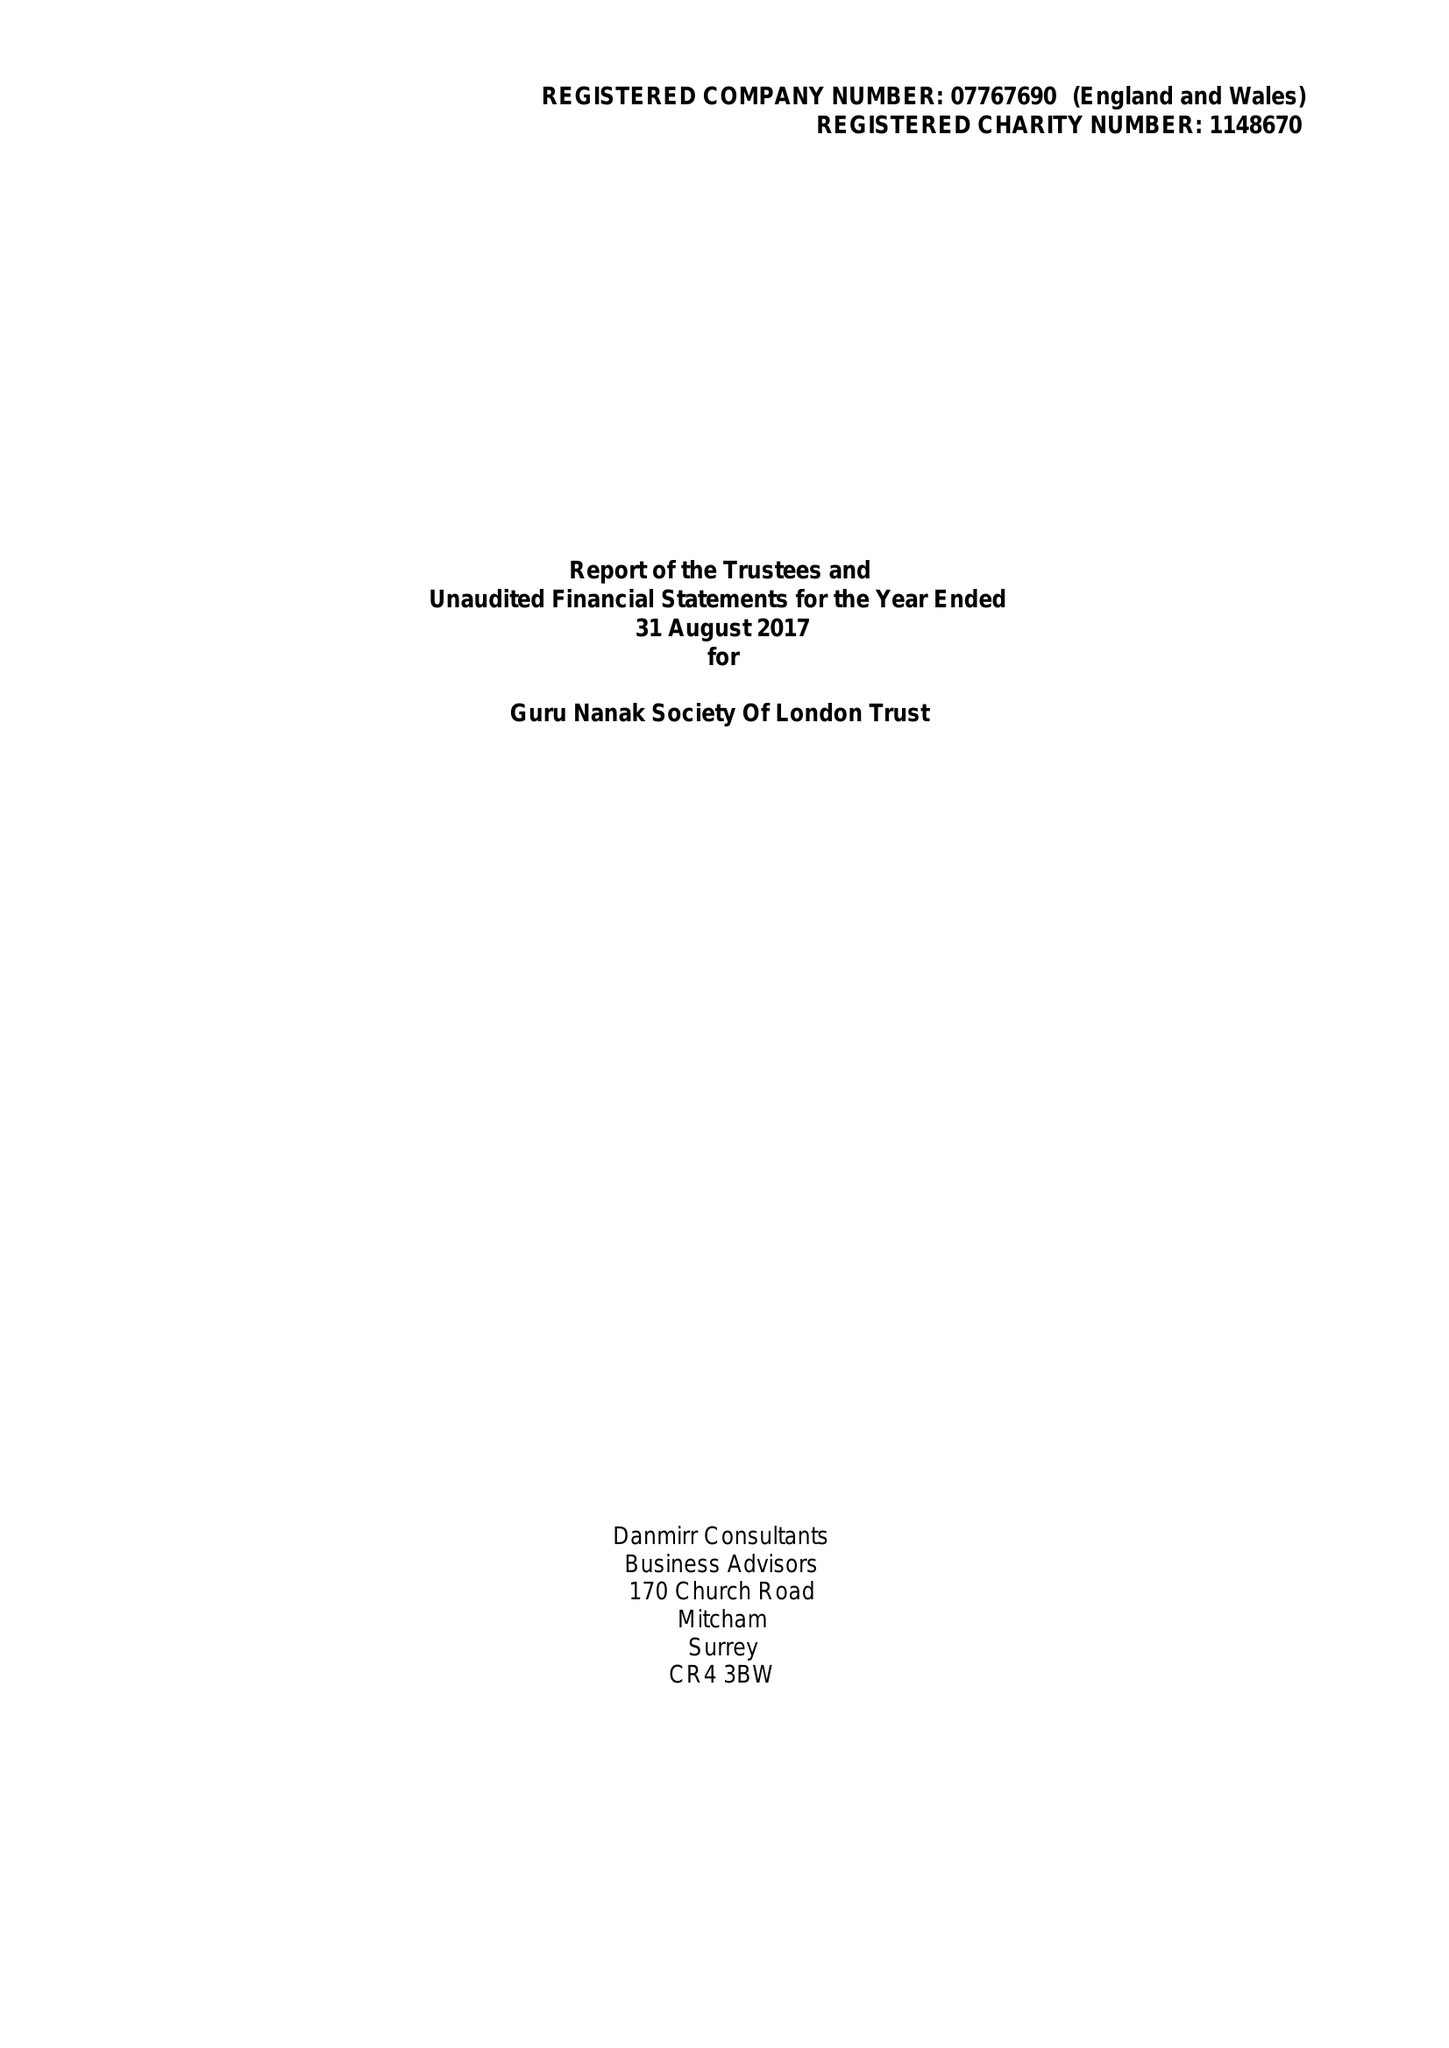What is the value for the charity_number?
Answer the question using a single word or phrase. 1148670 